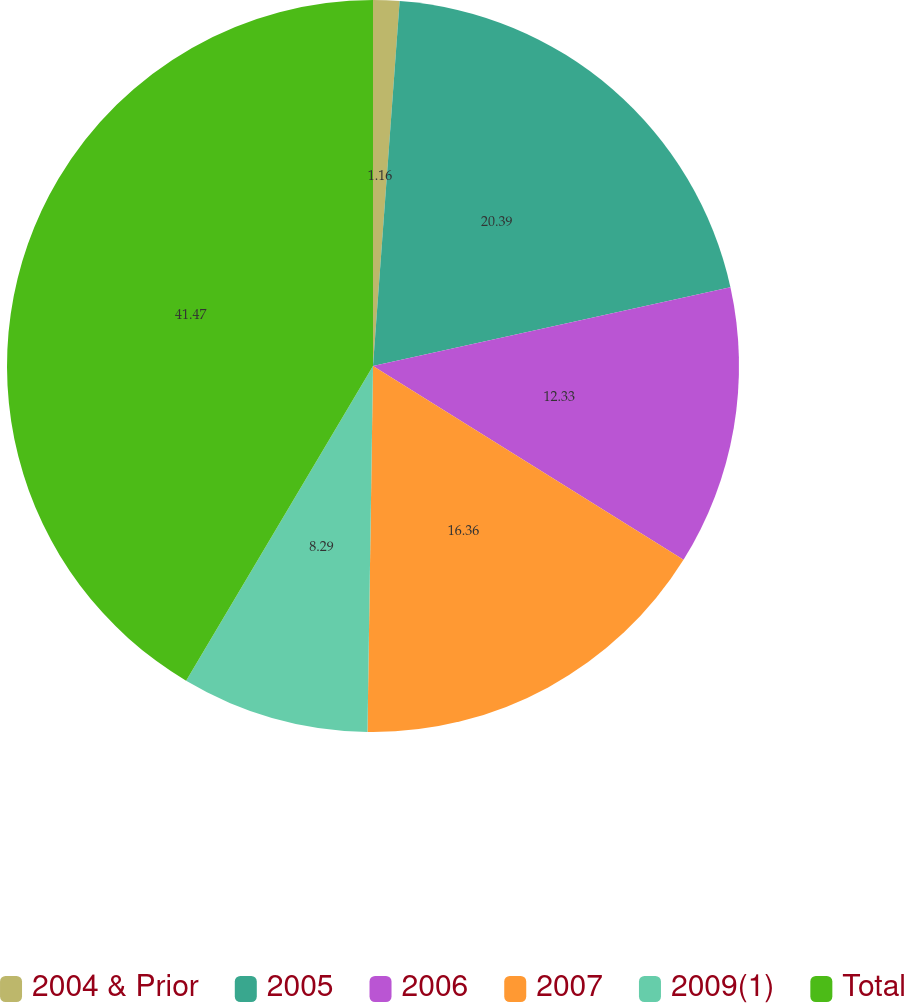<chart> <loc_0><loc_0><loc_500><loc_500><pie_chart><fcel>2004 & Prior<fcel>2005<fcel>2006<fcel>2007<fcel>2009(1)<fcel>Total<nl><fcel>1.16%<fcel>20.39%<fcel>12.33%<fcel>16.36%<fcel>8.29%<fcel>41.47%<nl></chart> 